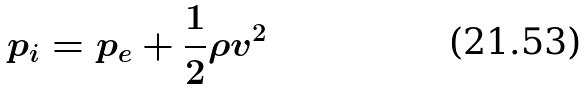<formula> <loc_0><loc_0><loc_500><loc_500>p _ { i } = p _ { e } + \frac { 1 } { 2 } \rho v ^ { 2 }</formula> 